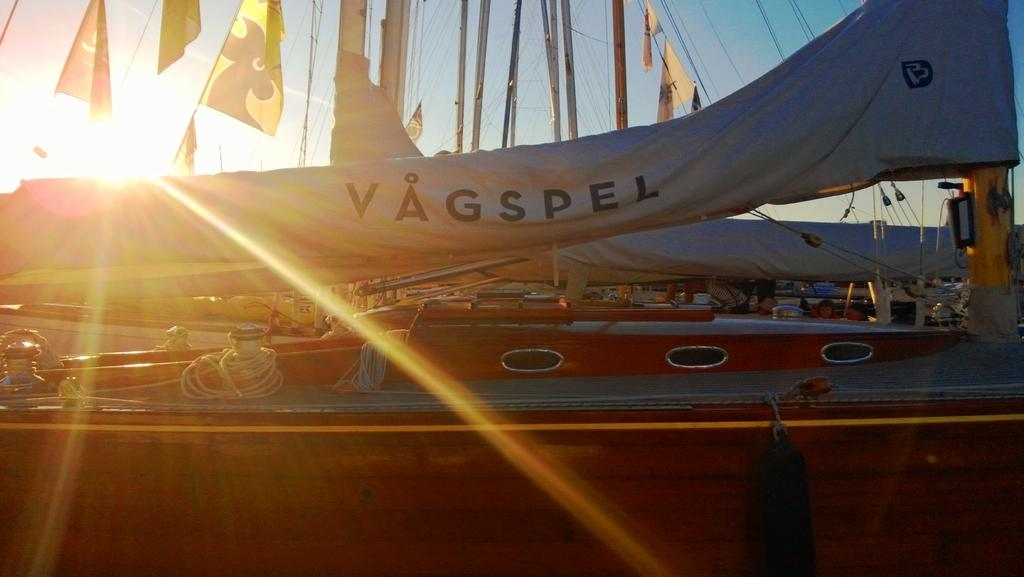<image>
Summarize the visual content of the image. A flag that says Vagspel on a ship 